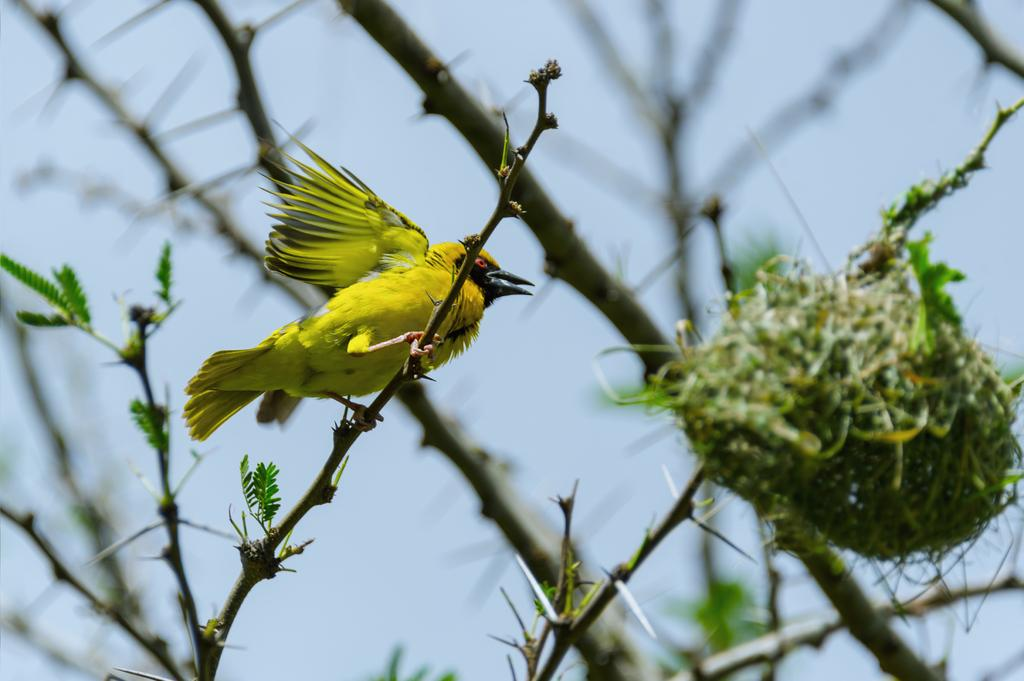What type of animal can be seen in the image? There is a bird in the image. Where is the bird located? The bird is sitting on a branch of a tree. What else can be seen in the background of the image? There is a nest and the sky visible in the background of the image. How is the background of the image depicted? The background of the image is blurred. What type of pleasure can be heard from the bell in the image? There is no bell present in the image, so it is not possible to determine what type of pleasure might be heard. 